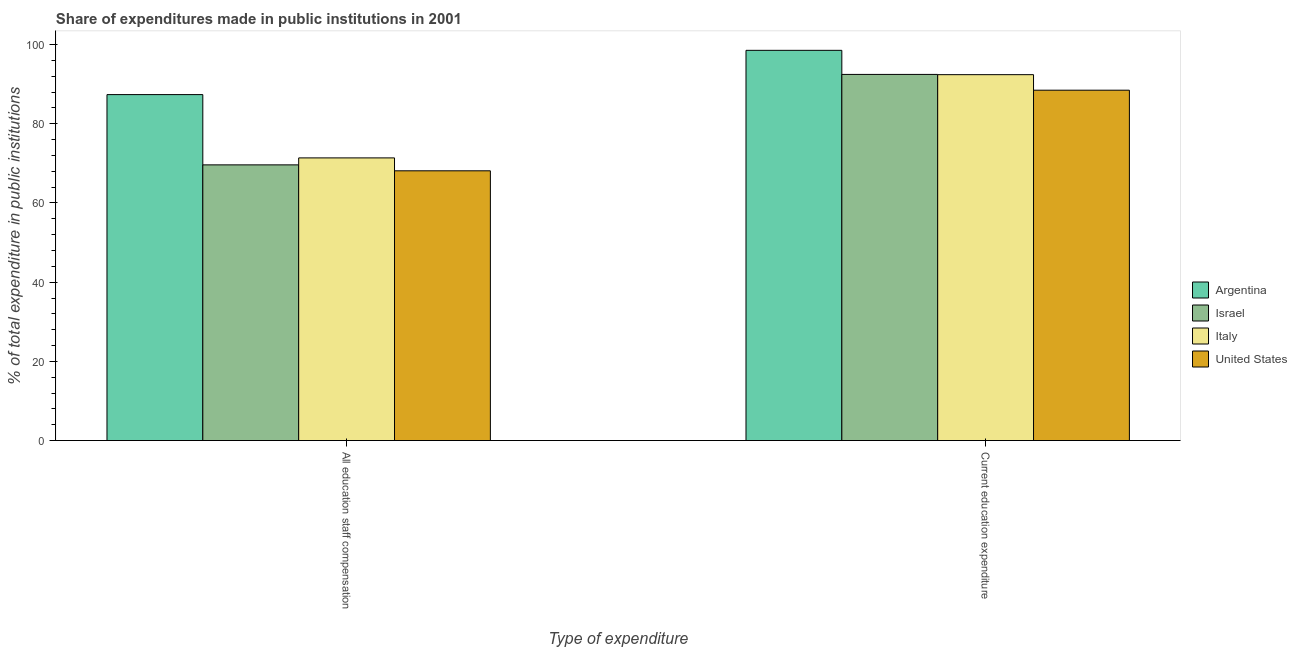How many different coloured bars are there?
Your response must be concise. 4. How many bars are there on the 1st tick from the left?
Ensure brevity in your answer.  4. What is the label of the 1st group of bars from the left?
Provide a short and direct response. All education staff compensation. What is the expenditure in staff compensation in United States?
Make the answer very short. 68.12. Across all countries, what is the maximum expenditure in staff compensation?
Provide a short and direct response. 87.36. Across all countries, what is the minimum expenditure in staff compensation?
Provide a short and direct response. 68.12. In which country was the expenditure in education maximum?
Provide a short and direct response. Argentina. In which country was the expenditure in staff compensation minimum?
Ensure brevity in your answer.  United States. What is the total expenditure in staff compensation in the graph?
Your answer should be compact. 296.47. What is the difference between the expenditure in education in Italy and that in United States?
Your answer should be very brief. 3.92. What is the difference between the expenditure in education in Italy and the expenditure in staff compensation in Argentina?
Keep it short and to the point. 5.03. What is the average expenditure in education per country?
Your response must be concise. 92.96. What is the difference between the expenditure in education and expenditure in staff compensation in United States?
Ensure brevity in your answer.  20.35. What is the ratio of the expenditure in education in United States to that in Argentina?
Provide a short and direct response. 0.9. Is the expenditure in staff compensation in Israel less than that in Italy?
Provide a succinct answer. Yes. What does the 2nd bar from the right in All education staff compensation represents?
Ensure brevity in your answer.  Italy. How many bars are there?
Offer a terse response. 8. What is the difference between two consecutive major ticks on the Y-axis?
Provide a succinct answer. 20. Are the values on the major ticks of Y-axis written in scientific E-notation?
Your answer should be compact. No. Does the graph contain any zero values?
Your response must be concise. No. How many legend labels are there?
Make the answer very short. 4. What is the title of the graph?
Offer a terse response. Share of expenditures made in public institutions in 2001. What is the label or title of the X-axis?
Your answer should be compact. Type of expenditure. What is the label or title of the Y-axis?
Keep it short and to the point. % of total expenditure in public institutions. What is the % of total expenditure in public institutions of Argentina in All education staff compensation?
Keep it short and to the point. 87.36. What is the % of total expenditure in public institutions of Israel in All education staff compensation?
Keep it short and to the point. 69.62. What is the % of total expenditure in public institutions of Italy in All education staff compensation?
Give a very brief answer. 71.37. What is the % of total expenditure in public institutions of United States in All education staff compensation?
Give a very brief answer. 68.12. What is the % of total expenditure in public institutions of Argentina in Current education expenditure?
Your response must be concise. 98.54. What is the % of total expenditure in public institutions in Israel in Current education expenditure?
Offer a very short reply. 92.45. What is the % of total expenditure in public institutions of Italy in Current education expenditure?
Offer a terse response. 92.39. What is the % of total expenditure in public institutions in United States in Current education expenditure?
Your answer should be very brief. 88.47. Across all Type of expenditure, what is the maximum % of total expenditure in public institutions in Argentina?
Your answer should be compact. 98.54. Across all Type of expenditure, what is the maximum % of total expenditure in public institutions of Israel?
Ensure brevity in your answer.  92.45. Across all Type of expenditure, what is the maximum % of total expenditure in public institutions in Italy?
Give a very brief answer. 92.39. Across all Type of expenditure, what is the maximum % of total expenditure in public institutions in United States?
Keep it short and to the point. 88.47. Across all Type of expenditure, what is the minimum % of total expenditure in public institutions in Argentina?
Ensure brevity in your answer.  87.36. Across all Type of expenditure, what is the minimum % of total expenditure in public institutions in Israel?
Offer a very short reply. 69.62. Across all Type of expenditure, what is the minimum % of total expenditure in public institutions of Italy?
Offer a terse response. 71.37. Across all Type of expenditure, what is the minimum % of total expenditure in public institutions in United States?
Your answer should be compact. 68.12. What is the total % of total expenditure in public institutions in Argentina in the graph?
Offer a very short reply. 185.89. What is the total % of total expenditure in public institutions of Israel in the graph?
Your answer should be very brief. 162.07. What is the total % of total expenditure in public institutions of Italy in the graph?
Provide a succinct answer. 163.77. What is the total % of total expenditure in public institutions of United States in the graph?
Give a very brief answer. 156.59. What is the difference between the % of total expenditure in public institutions of Argentina in All education staff compensation and that in Current education expenditure?
Your response must be concise. -11.18. What is the difference between the % of total expenditure in public institutions of Israel in All education staff compensation and that in Current education expenditure?
Make the answer very short. -22.84. What is the difference between the % of total expenditure in public institutions of Italy in All education staff compensation and that in Current education expenditure?
Ensure brevity in your answer.  -21.02. What is the difference between the % of total expenditure in public institutions in United States in All education staff compensation and that in Current education expenditure?
Provide a short and direct response. -20.35. What is the difference between the % of total expenditure in public institutions in Argentina in All education staff compensation and the % of total expenditure in public institutions in Israel in Current education expenditure?
Your response must be concise. -5.1. What is the difference between the % of total expenditure in public institutions in Argentina in All education staff compensation and the % of total expenditure in public institutions in Italy in Current education expenditure?
Give a very brief answer. -5.03. What is the difference between the % of total expenditure in public institutions in Argentina in All education staff compensation and the % of total expenditure in public institutions in United States in Current education expenditure?
Provide a short and direct response. -1.11. What is the difference between the % of total expenditure in public institutions of Israel in All education staff compensation and the % of total expenditure in public institutions of Italy in Current education expenditure?
Give a very brief answer. -22.77. What is the difference between the % of total expenditure in public institutions in Israel in All education staff compensation and the % of total expenditure in public institutions in United States in Current education expenditure?
Offer a terse response. -18.85. What is the difference between the % of total expenditure in public institutions in Italy in All education staff compensation and the % of total expenditure in public institutions in United States in Current education expenditure?
Offer a very short reply. -17.1. What is the average % of total expenditure in public institutions of Argentina per Type of expenditure?
Give a very brief answer. 92.95. What is the average % of total expenditure in public institutions of Israel per Type of expenditure?
Your answer should be very brief. 81.04. What is the average % of total expenditure in public institutions of Italy per Type of expenditure?
Ensure brevity in your answer.  81.88. What is the average % of total expenditure in public institutions in United States per Type of expenditure?
Your answer should be compact. 78.29. What is the difference between the % of total expenditure in public institutions in Argentina and % of total expenditure in public institutions in Israel in All education staff compensation?
Offer a terse response. 17.74. What is the difference between the % of total expenditure in public institutions in Argentina and % of total expenditure in public institutions in Italy in All education staff compensation?
Ensure brevity in your answer.  15.98. What is the difference between the % of total expenditure in public institutions of Argentina and % of total expenditure in public institutions of United States in All education staff compensation?
Your response must be concise. 19.24. What is the difference between the % of total expenditure in public institutions in Israel and % of total expenditure in public institutions in Italy in All education staff compensation?
Keep it short and to the point. -1.76. What is the difference between the % of total expenditure in public institutions of Israel and % of total expenditure in public institutions of United States in All education staff compensation?
Make the answer very short. 1.5. What is the difference between the % of total expenditure in public institutions of Italy and % of total expenditure in public institutions of United States in All education staff compensation?
Provide a short and direct response. 3.26. What is the difference between the % of total expenditure in public institutions of Argentina and % of total expenditure in public institutions of Israel in Current education expenditure?
Your answer should be very brief. 6.08. What is the difference between the % of total expenditure in public institutions of Argentina and % of total expenditure in public institutions of Italy in Current education expenditure?
Your answer should be very brief. 6.14. What is the difference between the % of total expenditure in public institutions in Argentina and % of total expenditure in public institutions in United States in Current education expenditure?
Give a very brief answer. 10.06. What is the difference between the % of total expenditure in public institutions in Israel and % of total expenditure in public institutions in Italy in Current education expenditure?
Your answer should be compact. 0.06. What is the difference between the % of total expenditure in public institutions in Israel and % of total expenditure in public institutions in United States in Current education expenditure?
Give a very brief answer. 3.98. What is the difference between the % of total expenditure in public institutions in Italy and % of total expenditure in public institutions in United States in Current education expenditure?
Your answer should be compact. 3.92. What is the ratio of the % of total expenditure in public institutions in Argentina in All education staff compensation to that in Current education expenditure?
Make the answer very short. 0.89. What is the ratio of the % of total expenditure in public institutions in Israel in All education staff compensation to that in Current education expenditure?
Your answer should be very brief. 0.75. What is the ratio of the % of total expenditure in public institutions in Italy in All education staff compensation to that in Current education expenditure?
Your answer should be very brief. 0.77. What is the ratio of the % of total expenditure in public institutions of United States in All education staff compensation to that in Current education expenditure?
Offer a terse response. 0.77. What is the difference between the highest and the second highest % of total expenditure in public institutions of Argentina?
Your answer should be compact. 11.18. What is the difference between the highest and the second highest % of total expenditure in public institutions in Israel?
Your answer should be very brief. 22.84. What is the difference between the highest and the second highest % of total expenditure in public institutions in Italy?
Provide a short and direct response. 21.02. What is the difference between the highest and the second highest % of total expenditure in public institutions in United States?
Your answer should be very brief. 20.35. What is the difference between the highest and the lowest % of total expenditure in public institutions of Argentina?
Your response must be concise. 11.18. What is the difference between the highest and the lowest % of total expenditure in public institutions in Israel?
Offer a very short reply. 22.84. What is the difference between the highest and the lowest % of total expenditure in public institutions in Italy?
Ensure brevity in your answer.  21.02. What is the difference between the highest and the lowest % of total expenditure in public institutions of United States?
Ensure brevity in your answer.  20.35. 